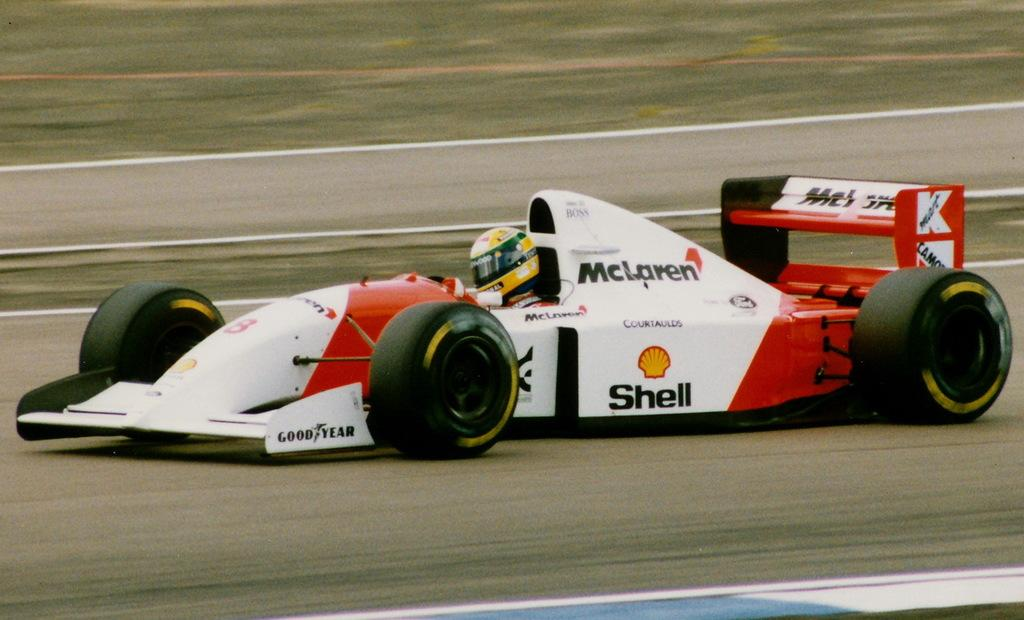<image>
Write a terse but informative summary of the picture. A driver with a yellow helmet is in a red and white race care sponsored by Shell. 